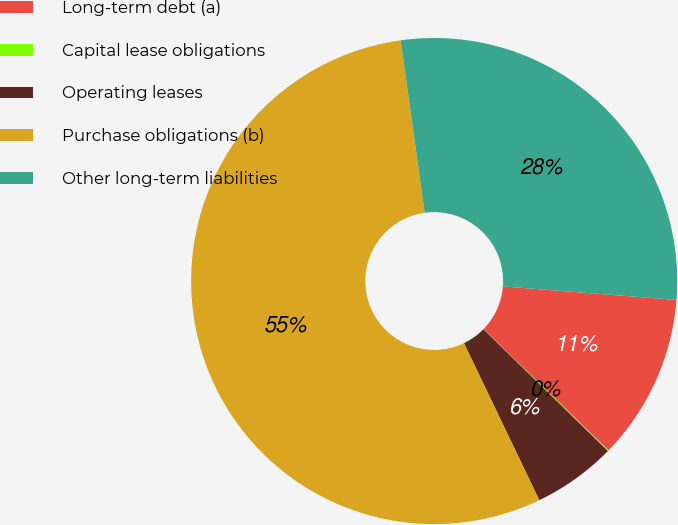<chart> <loc_0><loc_0><loc_500><loc_500><pie_chart><fcel>Long-term debt (a)<fcel>Capital lease obligations<fcel>Operating leases<fcel>Purchase obligations (b)<fcel>Other long-term liabilities<nl><fcel>11.03%<fcel>0.06%<fcel>5.55%<fcel>54.91%<fcel>28.44%<nl></chart> 